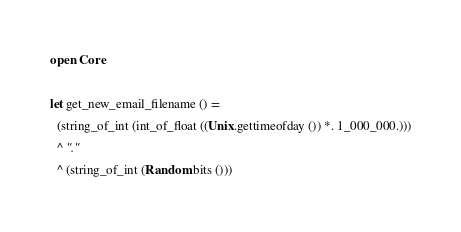<code> <loc_0><loc_0><loc_500><loc_500><_OCaml_>open Core

let get_new_email_filename () =
  (string_of_int (int_of_float ((Unix.gettimeofday ()) *. 1_000_000.)))
  ^ "."
  ^ (string_of_int (Random.bits ()))</code> 